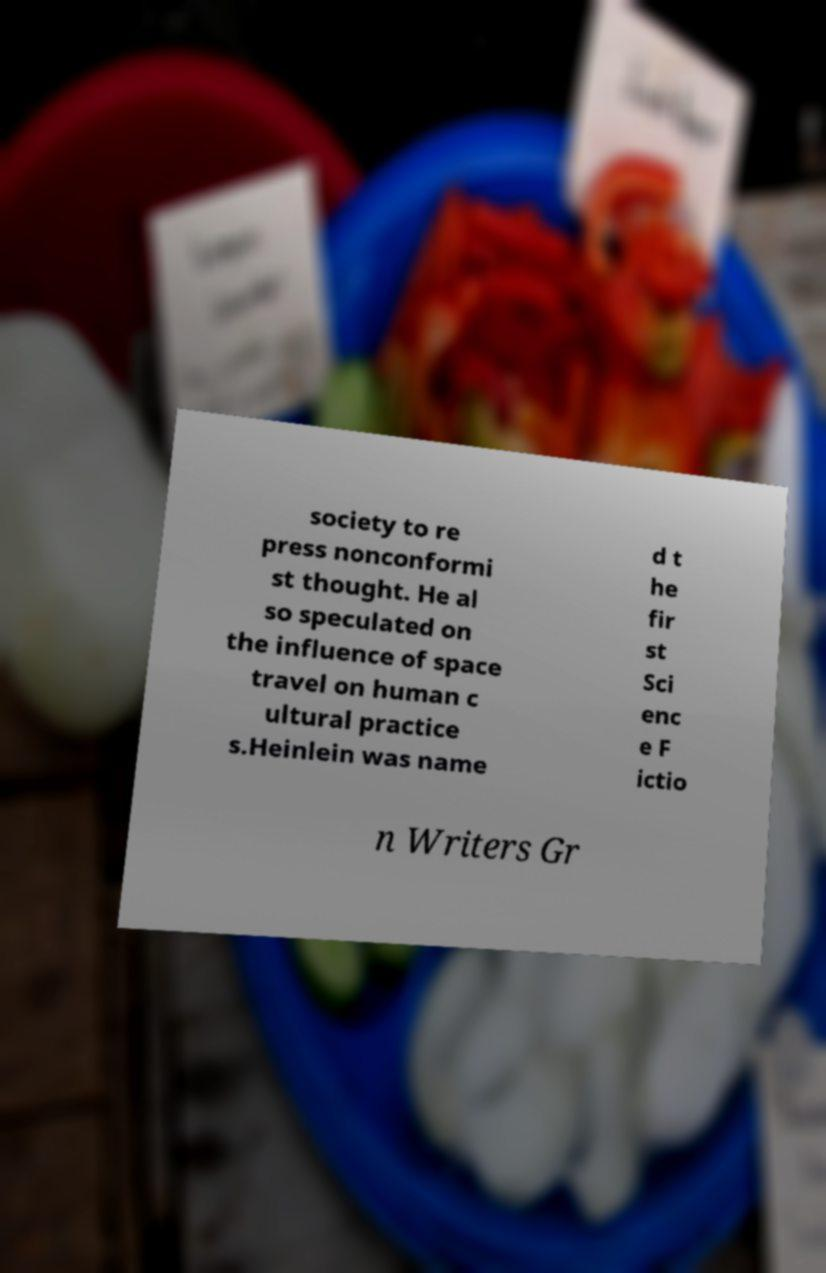Could you extract and type out the text from this image? society to re press nonconformi st thought. He al so speculated on the influence of space travel on human c ultural practice s.Heinlein was name d t he fir st Sci enc e F ictio n Writers Gr 